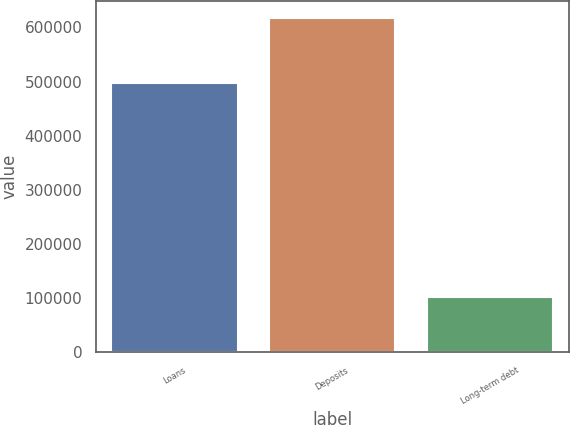<chart> <loc_0><loc_0><loc_500><loc_500><bar_chart><fcel>Loans<fcel>Deposits<fcel>Long-term debt<nl><fcel>497614<fcel>618409<fcel>101477<nl></chart> 